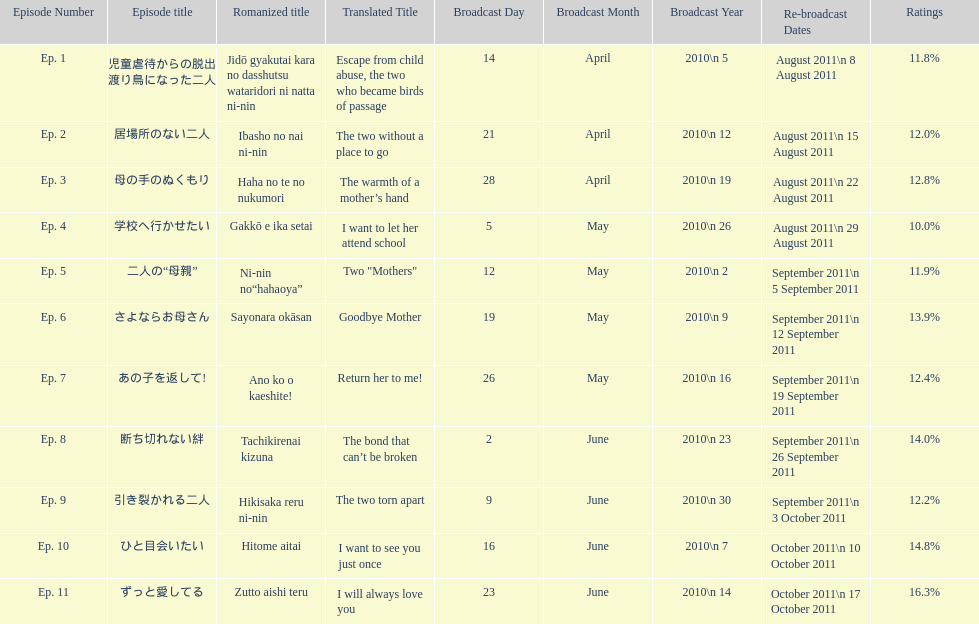What as the percentage total of ratings for episode 8? 14.0%. Would you be able to parse every entry in this table? {'header': ['Episode Number', 'Episode title', 'Romanized title', 'Translated Title', 'Broadcast Day', 'Broadcast Month', 'Broadcast Year', 'Re-broadcast Dates', 'Ratings'], 'rows': [['Ep. 1', '児童虐待からの脱出 渡り鳥になった二人', 'Jidō gyakutai kara no dasshutsu wataridori ni natta ni-nin', 'Escape from child abuse, the two who became birds of passage', '14', 'April', '2010\\n 5', 'August 2011\\n 8 August 2011', '11.8%'], ['Ep. 2', '居場所のない二人', 'Ibasho no nai ni-nin', 'The two without a place to go', '21', 'April', '2010\\n 12', 'August 2011\\n 15 August 2011', '12.0%'], ['Ep. 3', '母の手のぬくもり', 'Haha no te no nukumori', 'The warmth of a mother’s hand', '28', 'April', '2010\\n 19', 'August 2011\\n 22 August 2011', '12.8%'], ['Ep. 4', '学校へ行かせたい', 'Gakkō e ika setai', 'I want to let her attend school', '5', 'May', '2010\\n 26', 'August 2011\\n 29 August 2011', '10.0%'], ['Ep. 5', '二人の“母親”', 'Ni-nin no“hahaoya”', 'Two "Mothers"', '12', 'May', '2010\\n 2', 'September 2011\\n 5 September 2011', '11.9%'], ['Ep. 6', 'さよならお母さん', 'Sayonara okāsan', 'Goodbye Mother', '19', 'May', '2010\\n 9', 'September 2011\\n 12 September 2011', '13.9%'], ['Ep. 7', 'あの子を返して!', 'Ano ko o kaeshite!', 'Return her to me!', '26', 'May', '2010\\n 16', 'September 2011\\n 19 September 2011', '12.4%'], ['Ep. 8', '断ち切れない絆', 'Tachikirenai kizuna', 'The bond that can’t be broken', '2', 'June', '2010\\n 23', 'September 2011\\n 26 September 2011', '14.0%'], ['Ep. 9', '引き裂かれる二人', 'Hikisaka reru ni-nin', 'The two torn apart', '9', 'June', '2010\\n 30', 'September 2011\\n 3 October 2011', '12.2%'], ['Ep. 10', 'ひと目会いたい', 'Hitome aitai', 'I want to see you just once', '16', 'June', '2010\\n 7', 'October 2011\\n 10 October 2011', '14.8%'], ['Ep. 11', 'ずっと愛してる', 'Zutto aishi teru', 'I will always love you', '23', 'June', '2010\\n 14', 'October 2011\\n 17 October 2011', '16.3%']]} 